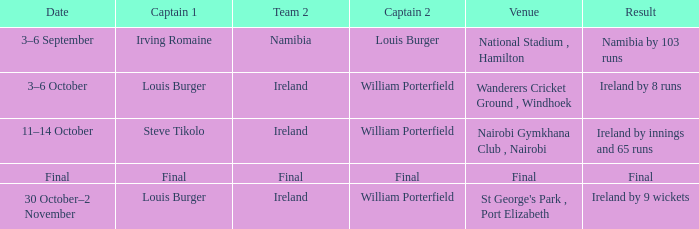Which Captain 2 has a Result of ireland by 8 runs? William Porterfield. 